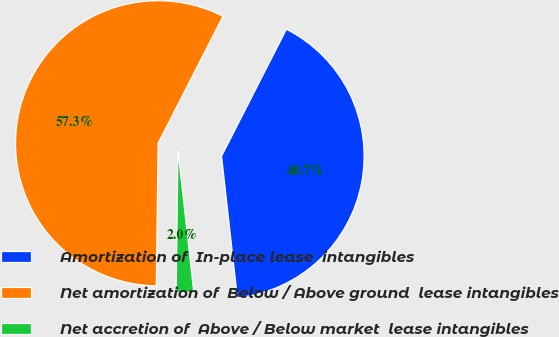Convert chart. <chart><loc_0><loc_0><loc_500><loc_500><pie_chart><fcel>Amortization of  In-place lease  intangibles<fcel>Net amortization of  Below / Above ground  lease intangibles<fcel>Net accretion of  Above / Below market  lease intangibles<nl><fcel>40.72%<fcel>57.32%<fcel>1.97%<nl></chart> 